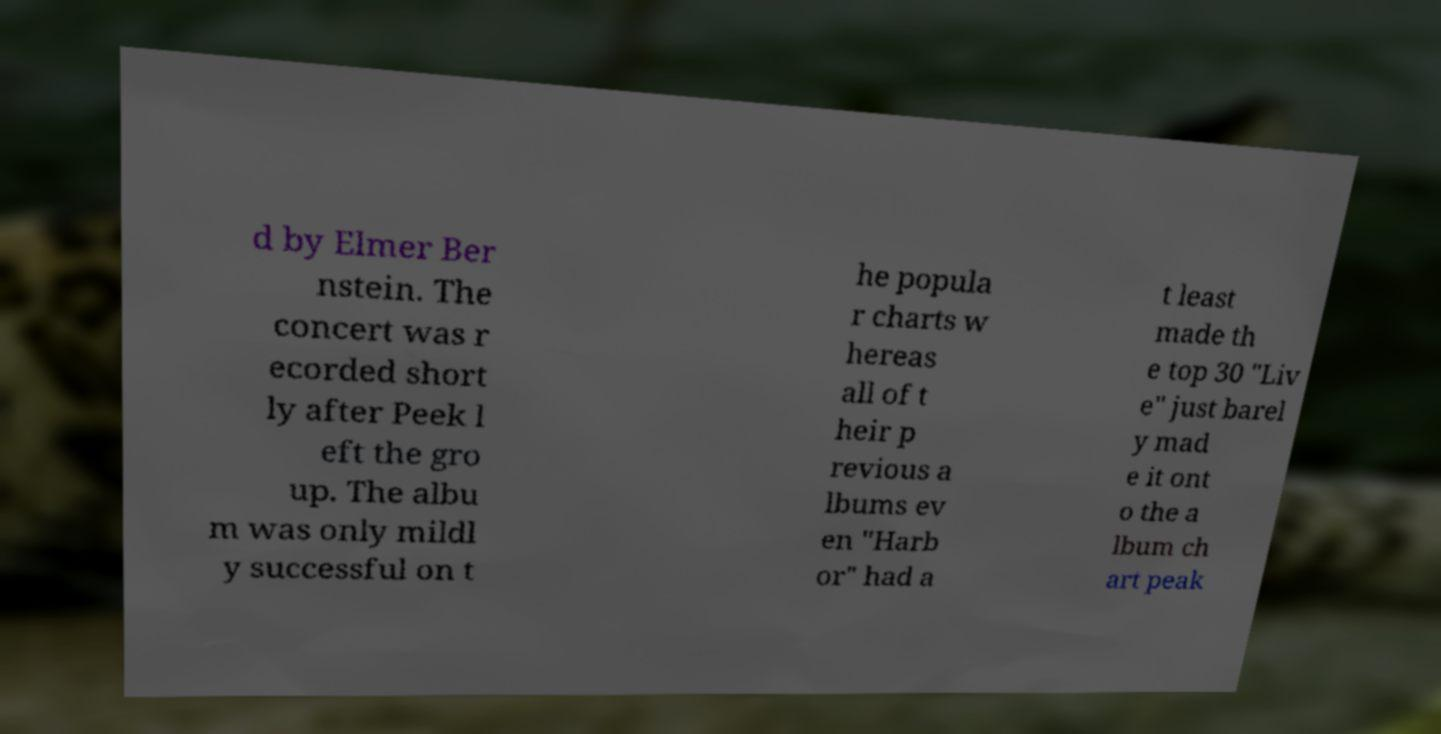I need the written content from this picture converted into text. Can you do that? d by Elmer Ber nstein. The concert was r ecorded short ly after Peek l eft the gro up. The albu m was only mildl y successful on t he popula r charts w hereas all of t heir p revious a lbums ev en "Harb or" had a t least made th e top 30 "Liv e" just barel y mad e it ont o the a lbum ch art peak 